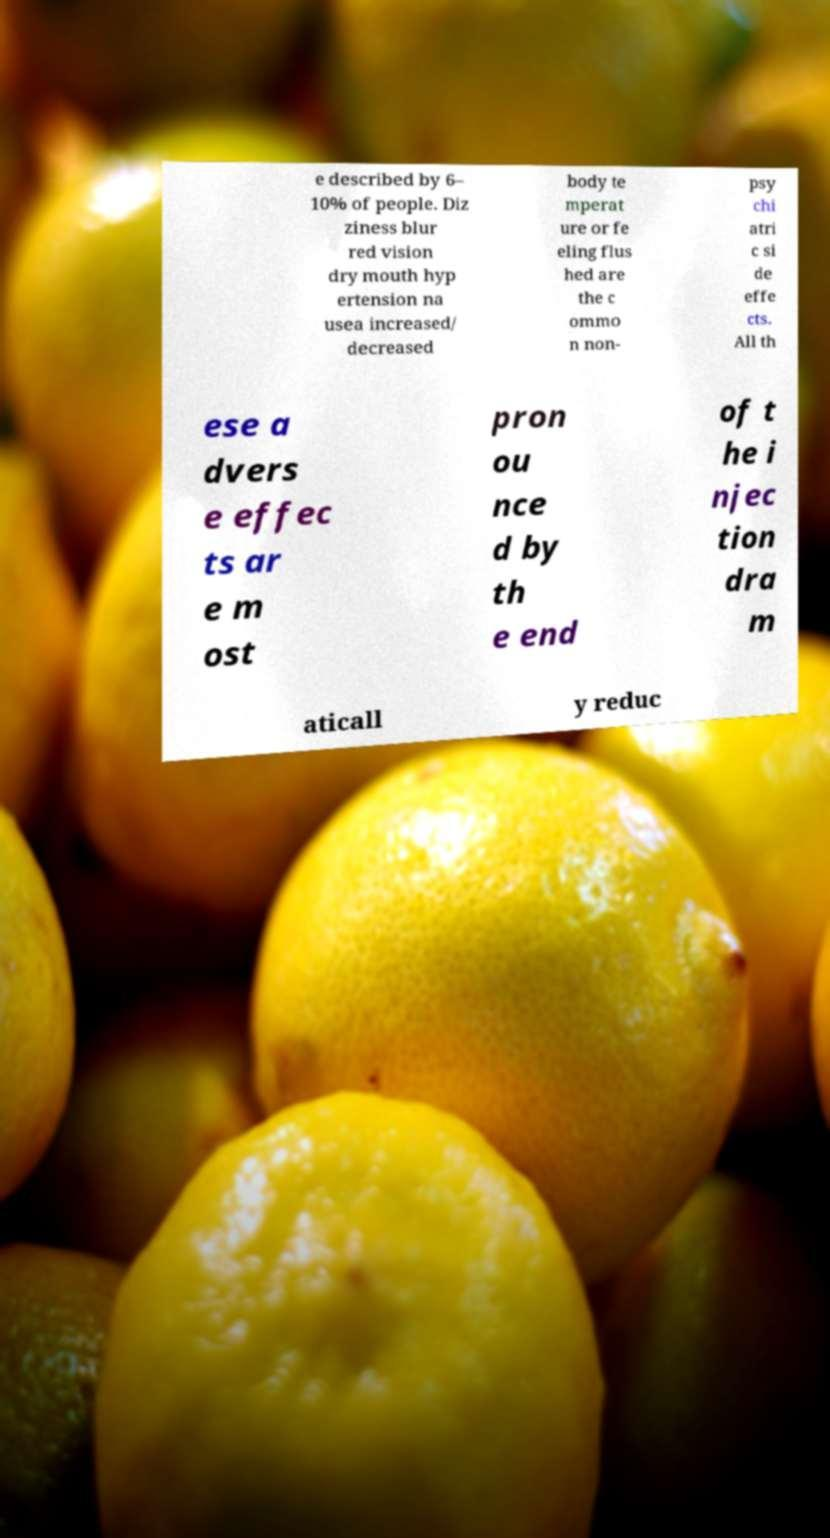For documentation purposes, I need the text within this image transcribed. Could you provide that? e described by 6– 10% of people. Diz ziness blur red vision dry mouth hyp ertension na usea increased/ decreased body te mperat ure or fe eling flus hed are the c ommo n non- psy chi atri c si de effe cts. All th ese a dvers e effec ts ar e m ost pron ou nce d by th e end of t he i njec tion dra m aticall y reduc 